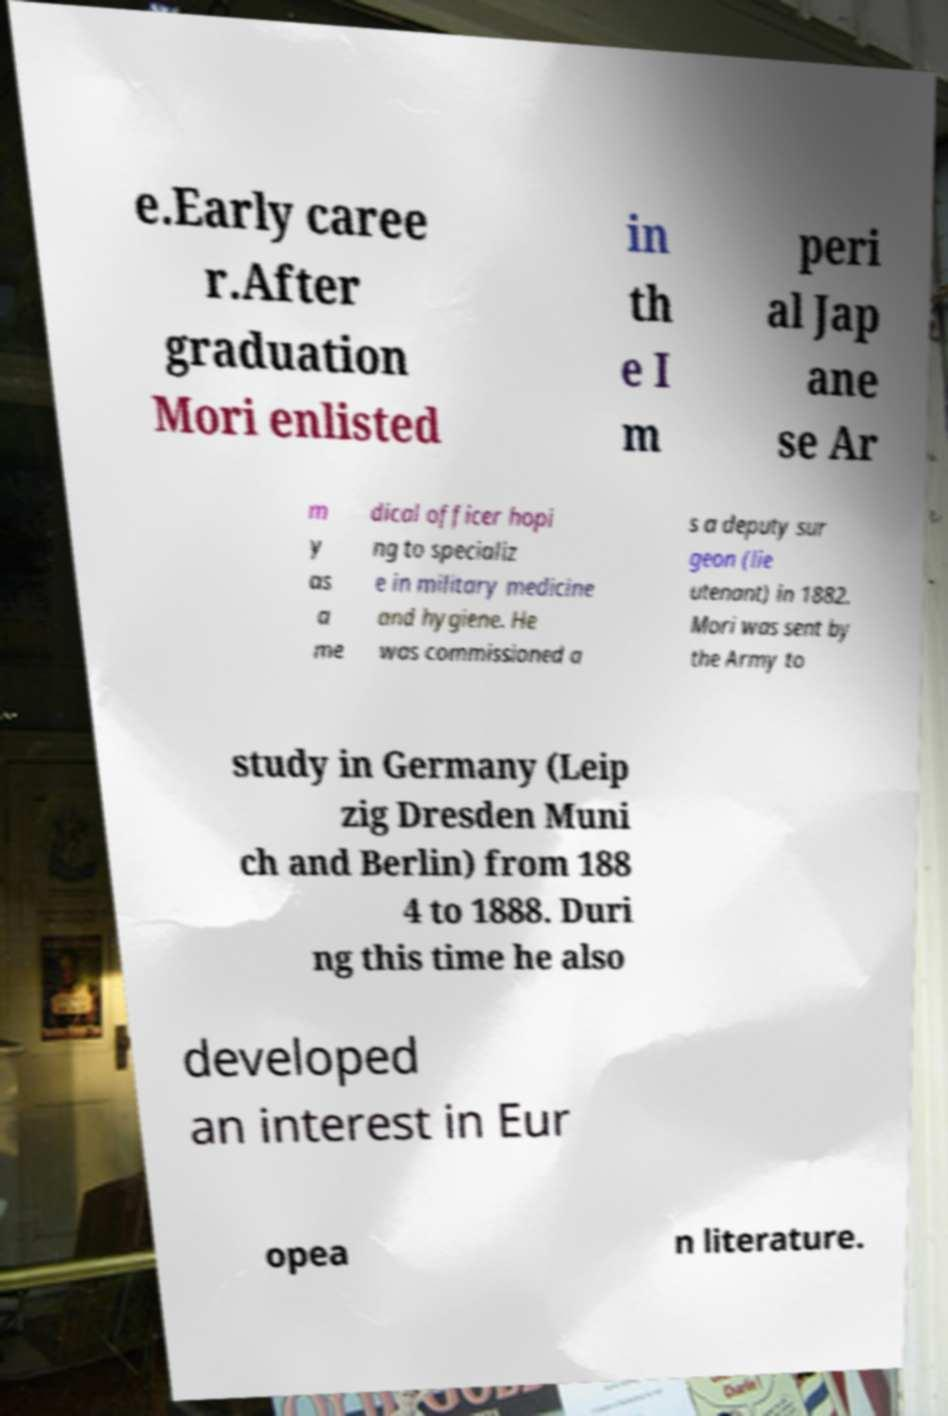There's text embedded in this image that I need extracted. Can you transcribe it verbatim? e.Early caree r.After graduation Mori enlisted in th e I m peri al Jap ane se Ar m y as a me dical officer hopi ng to specializ e in military medicine and hygiene. He was commissioned a s a deputy sur geon (lie utenant) in 1882. Mori was sent by the Army to study in Germany (Leip zig Dresden Muni ch and Berlin) from 188 4 to 1888. Duri ng this time he also developed an interest in Eur opea n literature. 